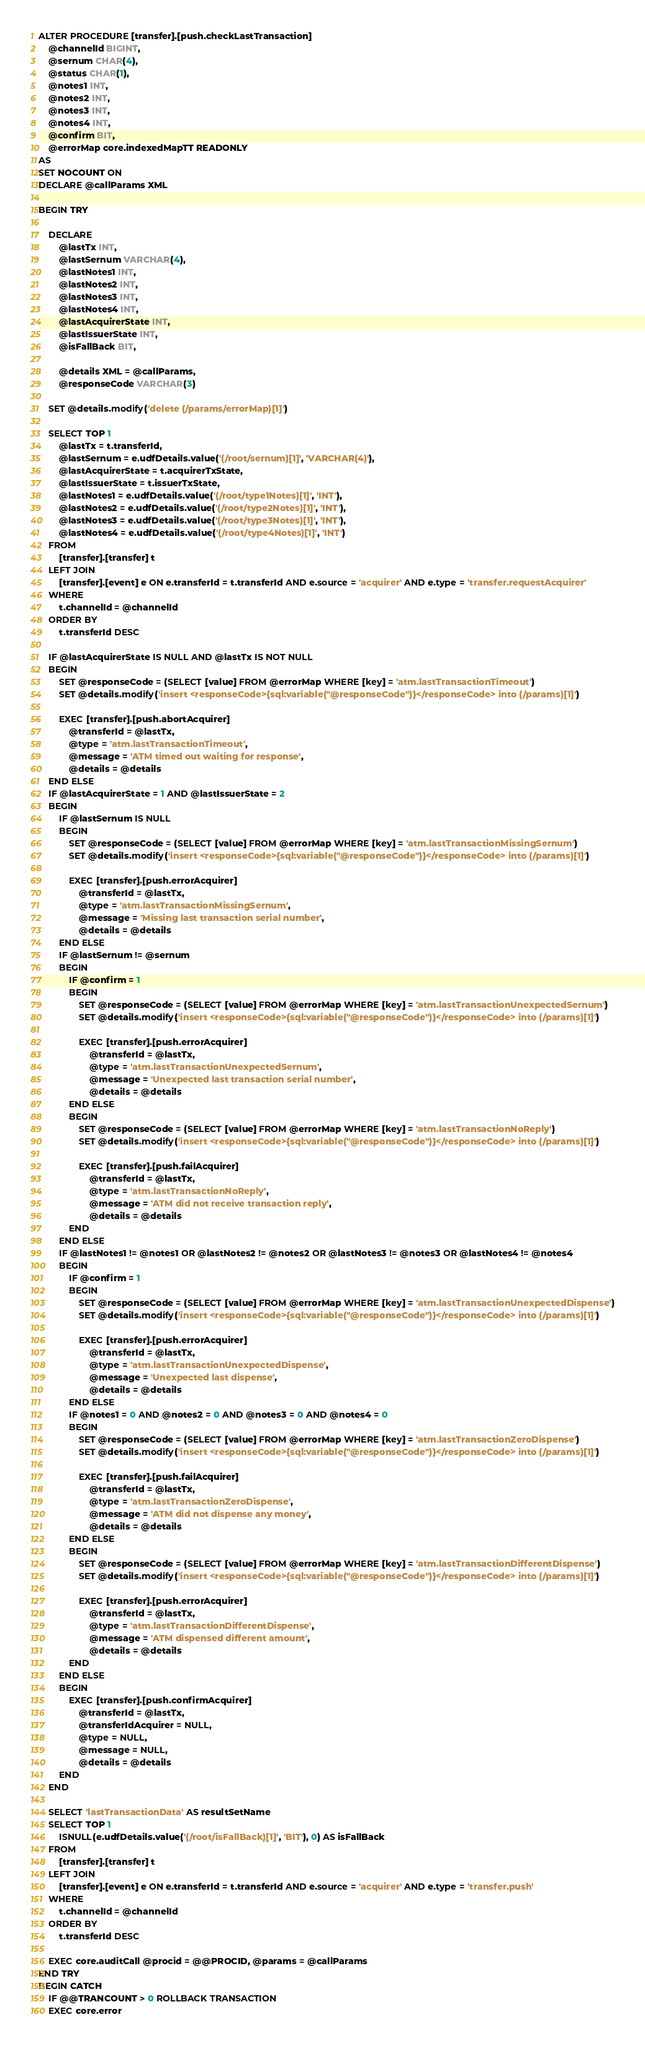<code> <loc_0><loc_0><loc_500><loc_500><_SQL_>ALTER PROCEDURE [transfer].[push.checkLastTransaction]
    @channelId BIGINT,
    @sernum CHAR(4),
    @status CHAR(1),
    @notes1 INT,
    @notes2 INT,
    @notes3 INT,
    @notes4 INT,
    @confirm BIT,
    @errorMap core.indexedMapTT READONLY
AS
SET NOCOUNT ON
DECLARE @callParams XML

BEGIN TRY

    DECLARE
        @lastTx INT,
        @lastSernum VARCHAR(4),
        @lastNotes1 INT,
        @lastNotes2 INT,
        @lastNotes3 INT,
        @lastNotes4 INT,
        @lastAcquirerState INT,
        @lastIssuerState INT,
        @isFallBack BIT,

        @details XML = @callParams,
        @responseCode VARCHAR(3)

    SET @details.modify('delete (/params/errorMap)[1]')

    SELECT TOP 1
        @lastTx = t.transferId,
        @lastSernum = e.udfDetails.value('(/root/sernum)[1]', 'VARCHAR(4)'),
        @lastAcquirerState = t.acquirerTxState,
        @lastIssuerState = t.issuerTxState,
        @lastNotes1 = e.udfDetails.value('(/root/type1Notes)[1]', 'INT'),
        @lastNotes2 = e.udfDetails.value('(/root/type2Notes)[1]', 'INT'),
        @lastNotes3 = e.udfDetails.value('(/root/type3Notes)[1]', 'INT'),
        @lastNotes4 = e.udfDetails.value('(/root/type4Notes)[1]', 'INT')
    FROM
        [transfer].[transfer] t
    LEFT JOIN
        [transfer].[event] e ON e.transferId = t.transferId AND e.source = 'acquirer' AND e.type = 'transfer.requestAcquirer'
    WHERE
        t.channelId = @channelId
    ORDER BY
        t.transferId DESC

    IF @lastAcquirerState IS NULL AND @lastTx IS NOT NULL
    BEGIN
        SET @responseCode = (SELECT [value] FROM @errorMap WHERE [key] = 'atm.lastTransactionTimeout')
        SET @details.modify('insert <responseCode>{sql:variable("@responseCode")}</responseCode> into (/params)[1]')

        EXEC [transfer].[push.abortAcquirer]
            @transferId = @lastTx,
            @type = 'atm.lastTransactionTimeout',
            @message = 'ATM timed out waiting for response',
            @details = @details
    END ELSE
    IF @lastAcquirerState = 1 AND @lastIssuerState = 2
    BEGIN
        IF @lastSernum IS NULL
        BEGIN
            SET @responseCode = (SELECT [value] FROM @errorMap WHERE [key] = 'atm.lastTransactionMissingSernum')
            SET @details.modify('insert <responseCode>{sql:variable("@responseCode")}</responseCode> into (/params)[1]')

            EXEC [transfer].[push.errorAcquirer]
                @transferId = @lastTx,
                @type = 'atm.lastTransactionMissingSernum',
                @message = 'Missing last transaction serial number',
                @details = @details
        END ELSE
        IF @lastSernum != @sernum
        BEGIN
            IF @confirm = 1
            BEGIN
                SET @responseCode = (SELECT [value] FROM @errorMap WHERE [key] = 'atm.lastTransactionUnexpectedSernum')
                SET @details.modify('insert <responseCode>{sql:variable("@responseCode")}</responseCode> into (/params)[1]')

                EXEC [transfer].[push.errorAcquirer]
                    @transferId = @lastTx,
                    @type = 'atm.lastTransactionUnexpectedSernum',
                    @message = 'Unexpected last transaction serial number',
                    @details = @details
            END ELSE
            BEGIN
                SET @responseCode = (SELECT [value] FROM @errorMap WHERE [key] = 'atm.lastTransactionNoReply')
                SET @details.modify('insert <responseCode>{sql:variable("@responseCode")}</responseCode> into (/params)[1]')

                EXEC [transfer].[push.failAcquirer]
                    @transferId = @lastTx,
                    @type = 'atm.lastTransactionNoReply',
                    @message = 'ATM did not receive transaction reply',
                    @details = @details
            END
        END ELSE
        IF @lastNotes1 != @notes1 OR @lastNotes2 != @notes2 OR @lastNotes3 != @notes3 OR @lastNotes4 != @notes4
        BEGIN
            IF @confirm = 1
            BEGIN
                SET @responseCode = (SELECT [value] FROM @errorMap WHERE [key] = 'atm.lastTransactionUnexpectedDispense')
                SET @details.modify('insert <responseCode>{sql:variable("@responseCode")}</responseCode> into (/params)[1]')

                EXEC [transfer].[push.errorAcquirer]
                    @transferId = @lastTx,
                    @type = 'atm.lastTransactionUnexpectedDispense',
                    @message = 'Unexpected last dispense',
                    @details = @details
            END ELSE
            IF @notes1 = 0 AND @notes2 = 0 AND @notes3 = 0 AND @notes4 = 0
            BEGIN
                SET @responseCode = (SELECT [value] FROM @errorMap WHERE [key] = 'atm.lastTransactionZeroDispense')
                SET @details.modify('insert <responseCode>{sql:variable("@responseCode")}</responseCode> into (/params)[1]')

                EXEC [transfer].[push.failAcquirer]
                    @transferId = @lastTx,
                    @type = 'atm.lastTransactionZeroDispense',
                    @message = 'ATM did not dispense any money',
                    @details = @details
            END ELSE
            BEGIN
                SET @responseCode = (SELECT [value] FROM @errorMap WHERE [key] = 'atm.lastTransactionDifferentDispense')
                SET @details.modify('insert <responseCode>{sql:variable("@responseCode")}</responseCode> into (/params)[1]')

                EXEC [transfer].[push.errorAcquirer]
                    @transferId = @lastTx,
                    @type = 'atm.lastTransactionDifferentDispense',
                    @message = 'ATM dispensed different amount',
                    @details = @details
            END
        END ELSE
        BEGIN
            EXEC [transfer].[push.confirmAcquirer]
                @transferId = @lastTx,
                @transferIdAcquirer = NULL,
                @type = NULL,
                @message = NULL,
                @details = @details
        END
    END

    SELECT 'lastTransactionData' AS resultSetName
    SELECT TOP 1
        ISNULL(e.udfDetails.value('(/root/isFallBack)[1]', 'BIT'), 0) AS isFallBack
    FROM
        [transfer].[transfer] t
    LEFT JOIN
        [transfer].[event] e ON e.transferId = t.transferId AND e.source = 'acquirer' AND e.type = 'transfer.push'
    WHERE
        t.channelId = @channelId
    ORDER BY
        t.transferId DESC

    EXEC core.auditCall @procid = @@PROCID, @params = @callParams
END TRY
BEGIN CATCH
    IF @@TRANCOUNT > 0 ROLLBACK TRANSACTION
    EXEC core.error</code> 